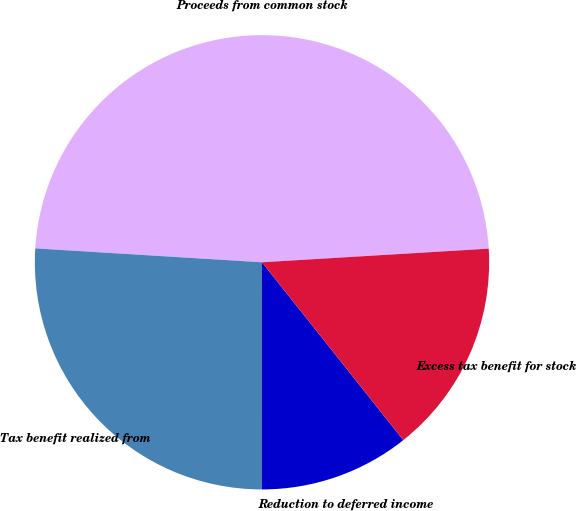Convert chart to OTSL. <chart><loc_0><loc_0><loc_500><loc_500><pie_chart><fcel>Proceeds from common stock<fcel>Tax benefit realized from<fcel>Reduction to deferred income<fcel>Excess tax benefit for stock<nl><fcel>48.07%<fcel>25.97%<fcel>10.69%<fcel>15.27%<nl></chart> 